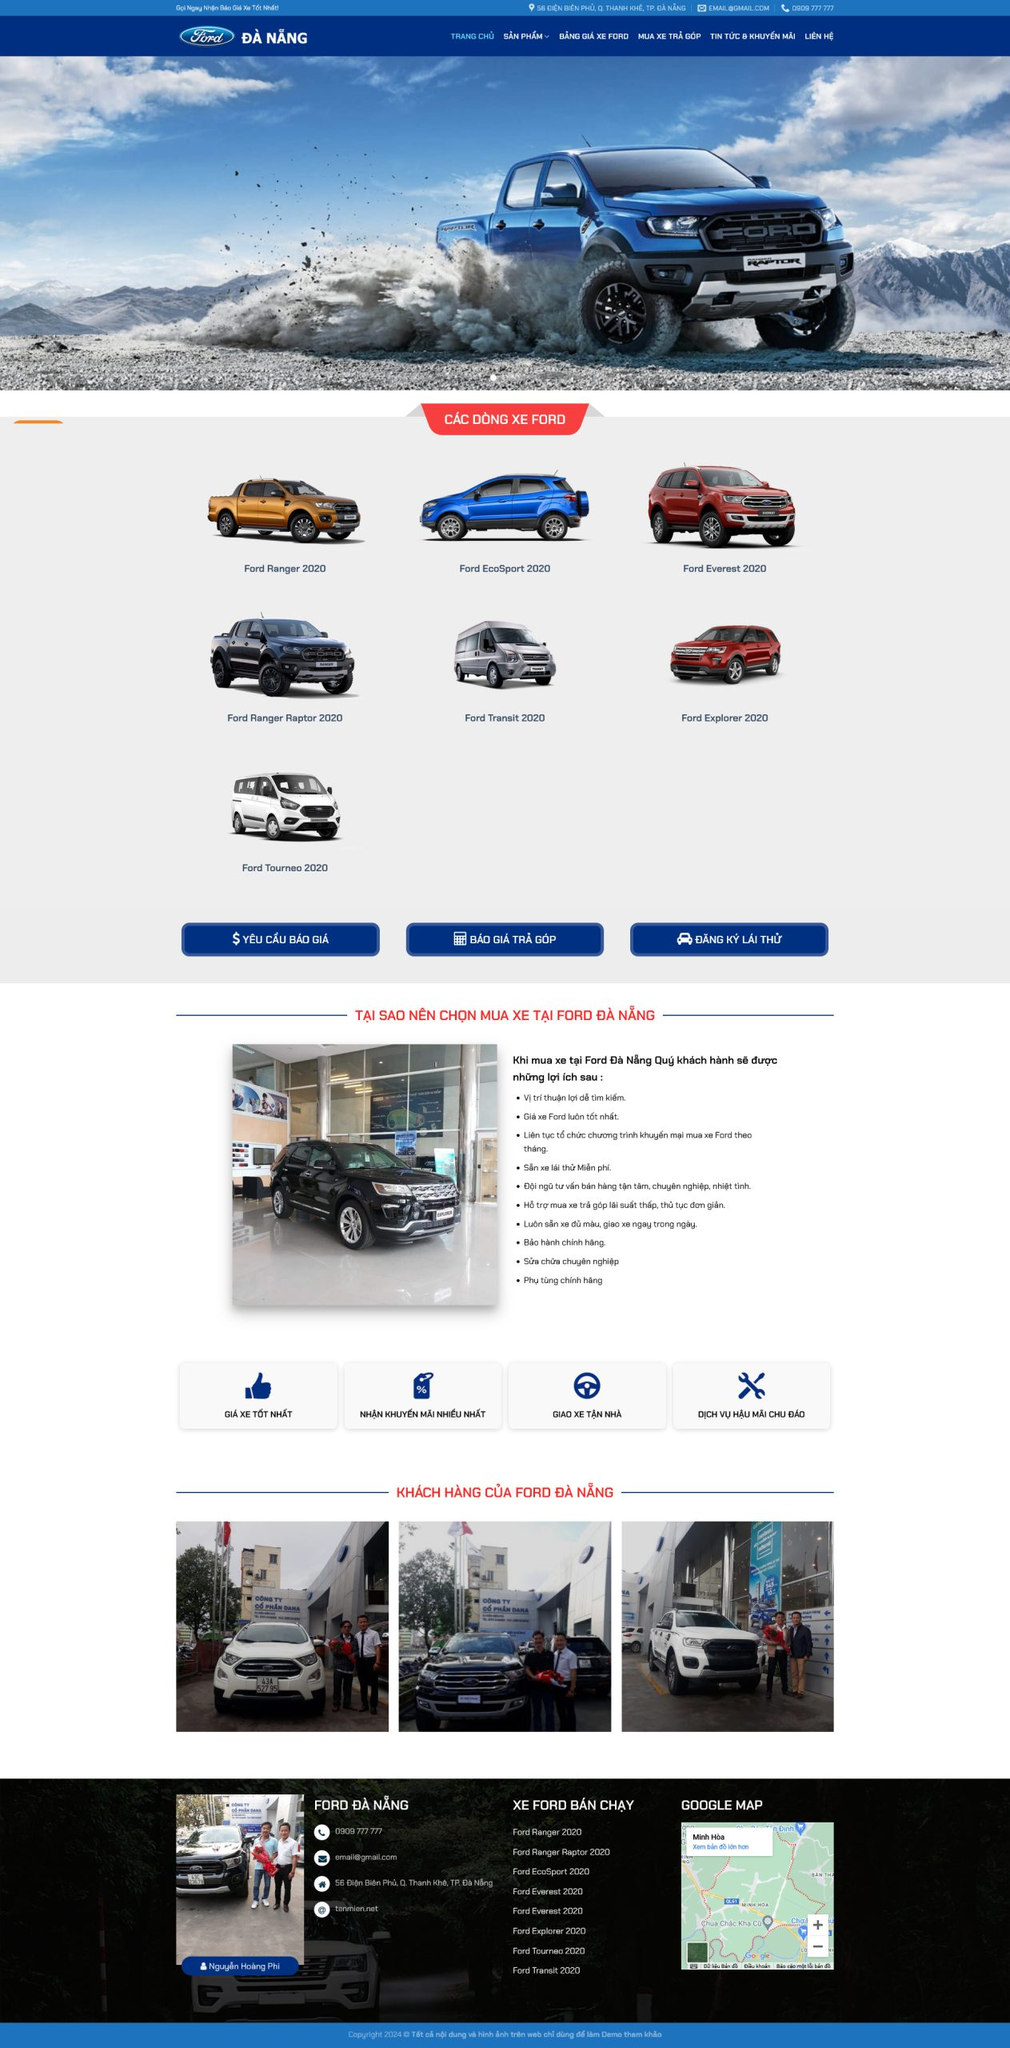Liệt kê 5 ngành nghề, lĩnh vực phù hợp với website này, phân cách các màu sắc bằng dấu phẩy. Chỉ trả về kết quả, phân cách bằng dấy phẩy
 ô tô, xe hơi, phương tiện vận tải, bán xe, dịch vụ hậu mãi 